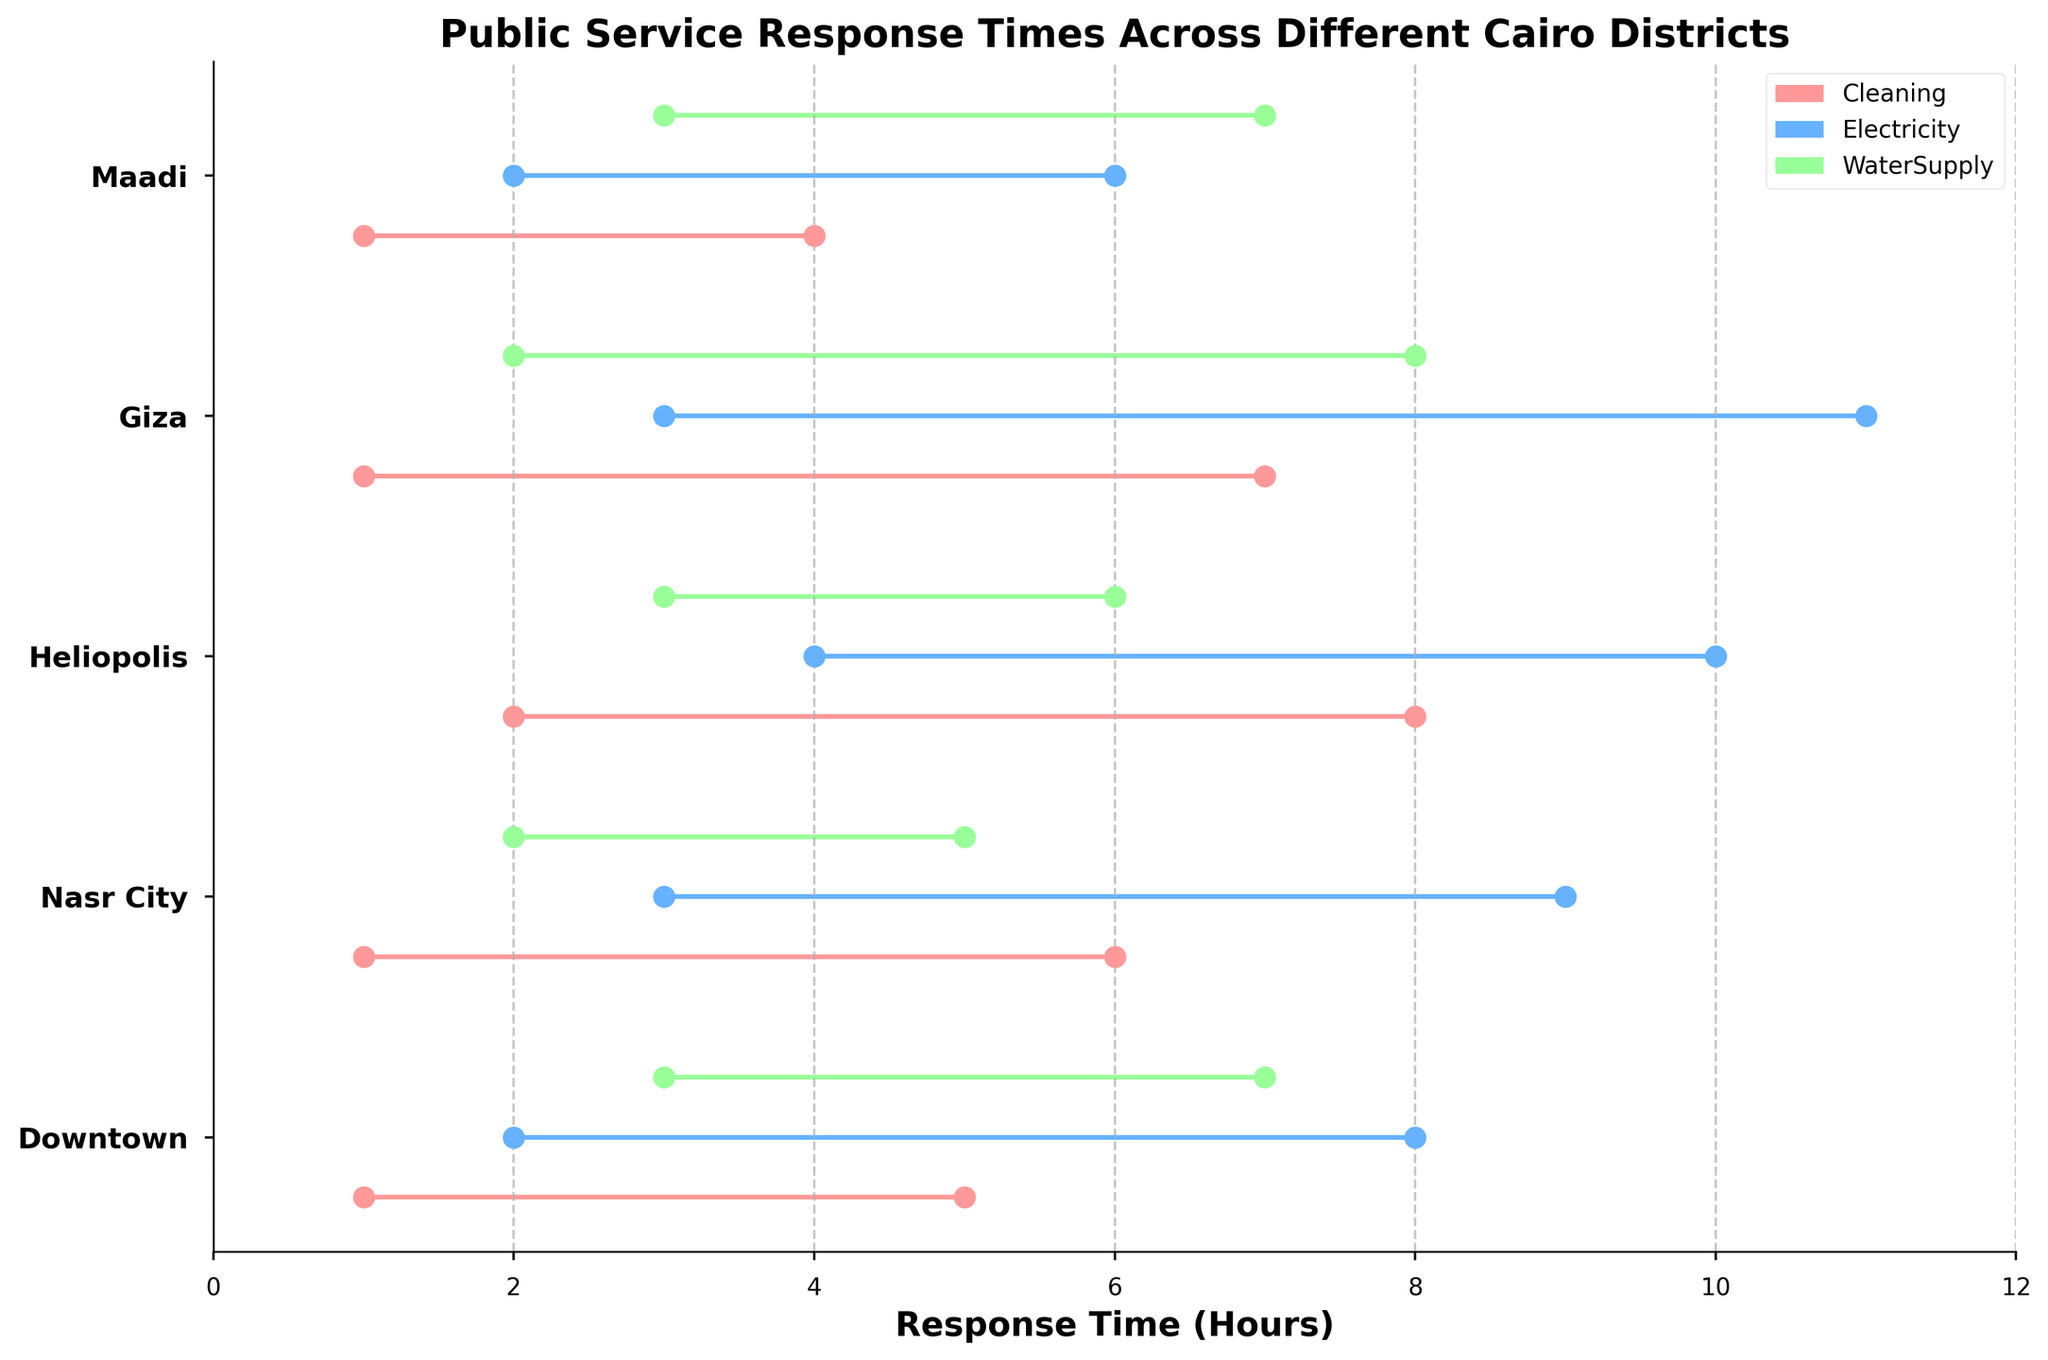What is the title of the plot? The title of the plot is located at the top center of the figure and clearly visible.
Answer: Public Service Response Times Across Different Cairo Districts Which service has the longest maximum response time in Giza? In the plot, find Giza on the Y-axis, then locate the color-coded lines for each service. The service with the longest maximum response time will have the line ending furthest to the right.
Answer: Electricity What is the shortest minimum response time among all services in Maadi? In the plot, find Maadi on the Y-axis, then identify the starting point (leftmost end) of the lines for all services. The shortest minimum response time is indicated by the leftmost point.
Answer: 1 hour Which district has the smallest range of response times for Cleaning services? For each district, observe the range between the start and end of the lines representing Cleaning services (red color). The smallest range has the shortest line length.
Answer: Maadi Compare the maximum response times for WaterSupply services in Downtown and Nasr City. Which district has a quicker maximum response time? Locate the maximum points for WaterSupply services (green color) for both Downtown and Nasr City, then compare the positions. The district with a smaller value (closer to the left) has a quicker maximum response time.
Answer: Nasr City How many districts have a minimum response time of 1 hour for Cleaning services? Identify Cleaning services (red color) on the plot and count the number of districts where the line starts at 1 hour.
Answer: 3 districts What is the difference between the maximum and minimum response times for Electricity in Heliopolis? Find the Electricity service (blue color) in Heliopolis, then subtract the minimum response time value from the maximum response time value.
Answer: 6 hours Which service in Downtown has a maximum response time greater than 7 hours? Look at the lines in Downtown to find which ones extend beyond 7 hours. The color of the line will indicate the service.
Answer: Electricity By how many hours does the maximum response time for Cleaning services in Heliopolis exceed that in Maadi? Identify the maximum response times for Cleaning (red color) in both Heliopolis and Maadi, then subtract Maadi’s value from Heliopolis’s value.
Answer: 4 hours Among all the districts and services, what is the maximum overall response time? Look across all districts and services for the rightmost end of any line, indicating the maximum overall response time.
Answer: 11 hours 